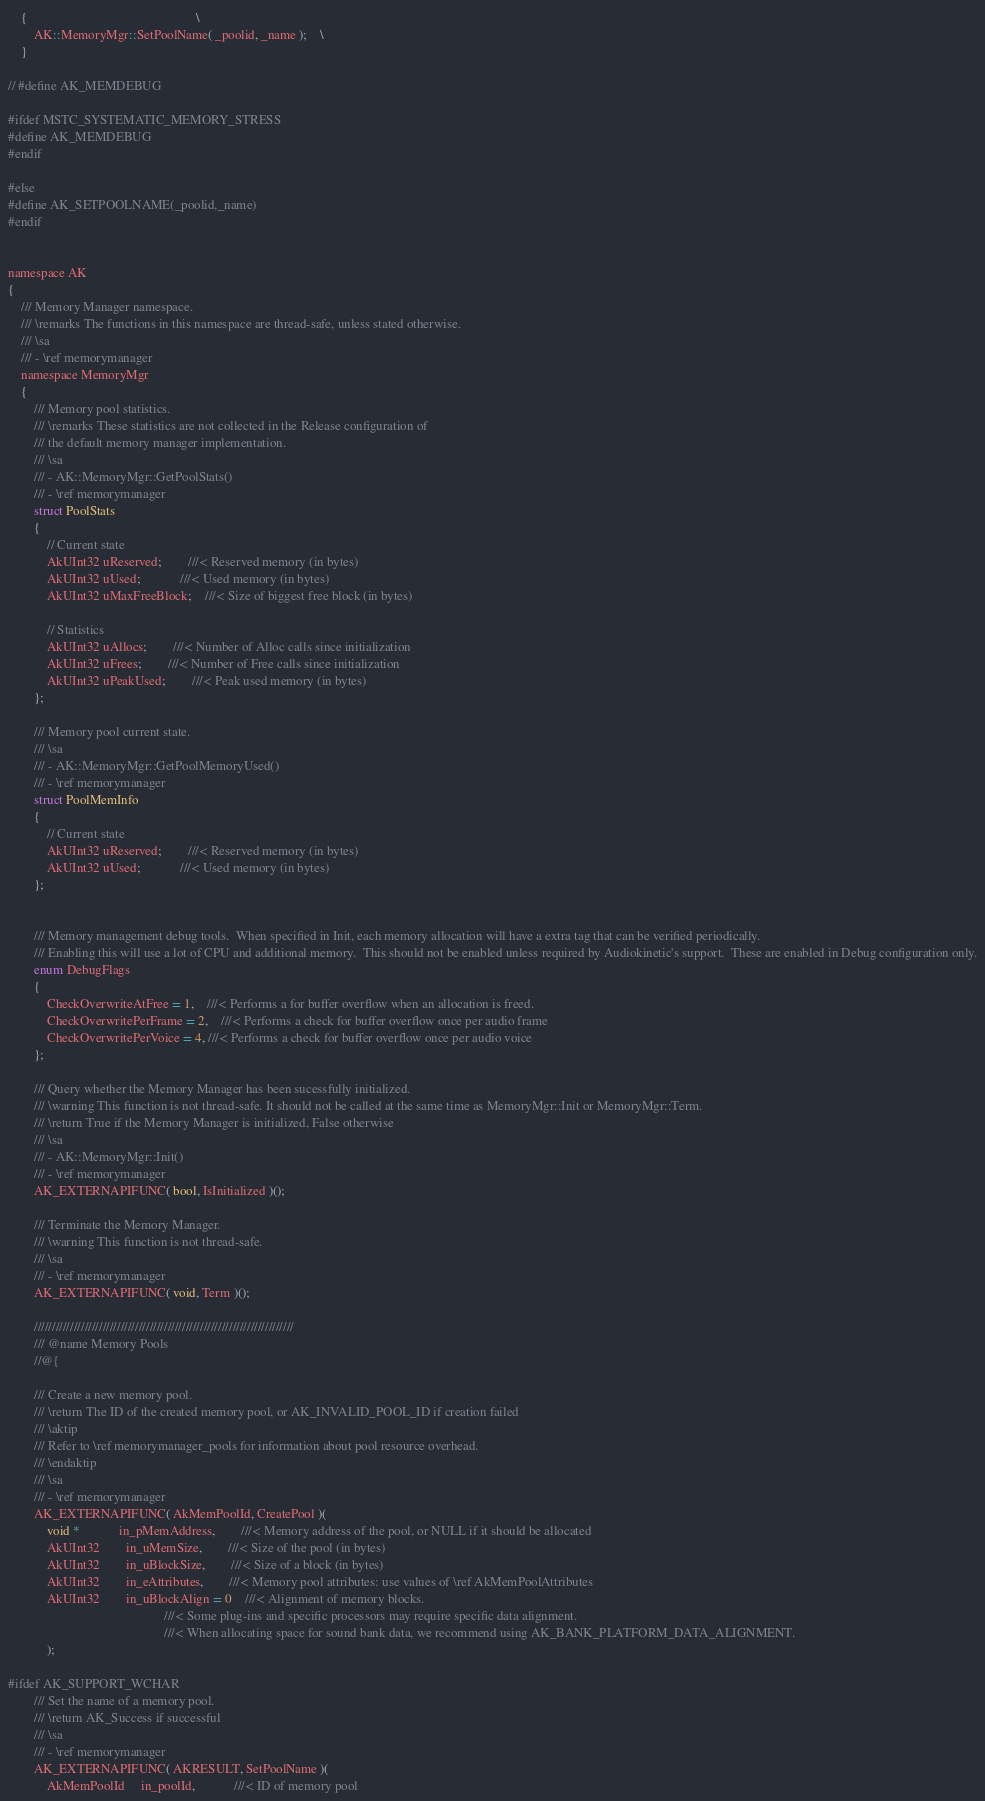Convert code to text. <code><loc_0><loc_0><loc_500><loc_500><_C_>	{													\
		AK::MemoryMgr::SetPoolName( _poolid, _name );	\
	}

// #define AK_MEMDEBUG

#ifdef MSTC_SYSTEMATIC_MEMORY_STRESS
#define AK_MEMDEBUG
#endif

#else
#define AK_SETPOOLNAME(_poolid,_name)
#endif


namespace AK
{   
	/// Memory Manager namespace.
	/// \remarks The functions in this namespace are thread-safe, unless stated otherwise.
	/// \sa
	/// - \ref memorymanager
	namespace MemoryMgr
	{
		/// Memory pool statistics. 
		/// \remarks These statistics are not collected in the Release configuration of 
		/// the default memory manager implementation.
		/// \sa 
		/// - AK::MemoryMgr::GetPoolStats()
		/// - \ref memorymanager
		struct PoolStats
		{
			// Current state
			AkUInt32 uReserved;		///< Reserved memory (in bytes)
			AkUInt32 uUsed;			///< Used memory (in bytes)
			AkUInt32 uMaxFreeBlock;	///< Size of biggest free block (in bytes)

			// Statistics
			AkUInt32 uAllocs;		///< Number of Alloc calls since initialization
			AkUInt32 uFrees;		///< Number of Free calls since initialization
			AkUInt32 uPeakUsed;		///< Peak used memory (in bytes)
		};

		/// Memory pool current state. 
		/// \sa 
		/// - AK::MemoryMgr::GetPoolMemoryUsed()
		/// - \ref memorymanager
		struct PoolMemInfo
		{
			// Current state
			AkUInt32 uReserved;		///< Reserved memory (in bytes)
			AkUInt32 uUsed;			///< Used memory (in bytes)
		};


		/// Memory management debug tools.  When specified in Init, each memory allocation will have a extra tag that can be verified periodically.
		/// Enabling this will use a lot of CPU and additional memory.  This should not be enabled unless required by Audiokinetic's support.  These are enabled in Debug configuration only.
		enum DebugFlags
		{
			CheckOverwriteAtFree = 1,	///< Performs a for buffer overflow when an allocation is freed.
			CheckOverwritePerFrame = 2,	///< Performs a check for buffer overflow once per audio frame
			CheckOverwritePerVoice = 4, ///< Performs a check for buffer overflow once per audio voice			
		};

		/// Query whether the Memory Manager has been sucessfully initialized.
		/// \warning This function is not thread-safe. It should not be called at the same time as MemoryMgr::Init or MemoryMgr::Term.
		/// \return True if the Memory Manager is initialized, False otherwise
		/// \sa 
		/// - AK::MemoryMgr::Init()
		/// - \ref memorymanager
		AK_EXTERNAPIFUNC( bool, IsInitialized )();

		/// Terminate the Memory Manager.
		/// \warning This function is not thread-safe. 
		/// \sa
		/// - \ref memorymanager
	    AK_EXTERNAPIFUNC( void, Term )();

		////////////////////////////////////////////////////////////////////////
		/// @name Memory Pools
		//@{

		/// Create a new memory pool.
		/// \return The ID of the created memory pool, or AK_INVALID_POOL_ID if creation failed
		/// \aktip
		/// Refer to \ref memorymanager_pools for information about pool resource overhead.
		/// \endaktip
		/// \sa
		/// - \ref memorymanager
		AK_EXTERNAPIFUNC( AkMemPoolId, CreatePool )(
			void *			in_pMemAddress,		///< Memory address of the pool, or NULL if it should be allocated
			AkUInt32		in_uMemSize,		///< Size of the pool (in bytes)
			AkUInt32		in_uBlockSize,		///< Size of a block (in bytes)
			AkUInt32		in_eAttributes,		///< Memory pool attributes: use values of \ref AkMemPoolAttributes
			AkUInt32        in_uBlockAlign = 0	///< Alignment of memory blocks. 
												///< Some plug-ins and specific processors may require specific data alignment.
												///< When allocating space for sound bank data, we recommend using AK_BANK_PLATFORM_DATA_ALIGNMENT.
			);

#ifdef AK_SUPPORT_WCHAR
		/// Set the name of a memory pool.
		/// \return AK_Success if successful
		/// \sa
		/// - \ref memorymanager
		AK_EXTERNAPIFUNC( AKRESULT, SetPoolName )( 
			AkMemPoolId     in_poolId,			///< ID of memory pool</code> 